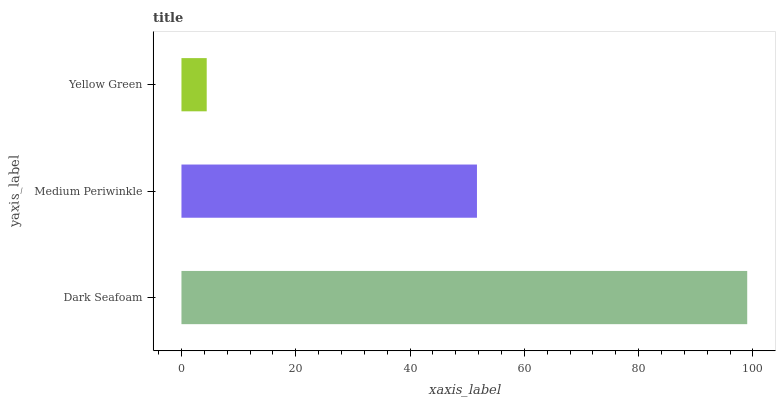Is Yellow Green the minimum?
Answer yes or no. Yes. Is Dark Seafoam the maximum?
Answer yes or no. Yes. Is Medium Periwinkle the minimum?
Answer yes or no. No. Is Medium Periwinkle the maximum?
Answer yes or no. No. Is Dark Seafoam greater than Medium Periwinkle?
Answer yes or no. Yes. Is Medium Periwinkle less than Dark Seafoam?
Answer yes or no. Yes. Is Medium Periwinkle greater than Dark Seafoam?
Answer yes or no. No. Is Dark Seafoam less than Medium Periwinkle?
Answer yes or no. No. Is Medium Periwinkle the high median?
Answer yes or no. Yes. Is Medium Periwinkle the low median?
Answer yes or no. Yes. Is Dark Seafoam the high median?
Answer yes or no. No. Is Dark Seafoam the low median?
Answer yes or no. No. 